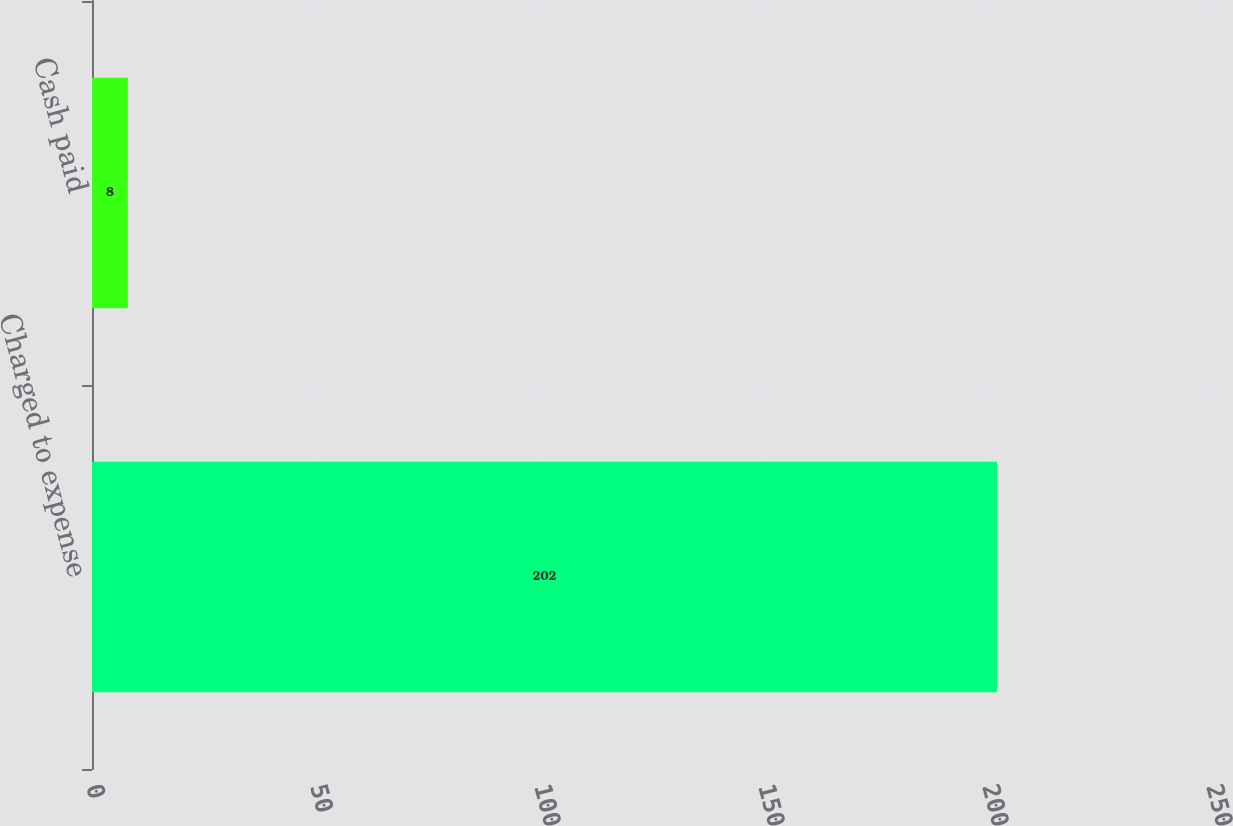Convert chart to OTSL. <chart><loc_0><loc_0><loc_500><loc_500><bar_chart><fcel>Charged to expense<fcel>Cash paid<nl><fcel>202<fcel>8<nl></chart> 